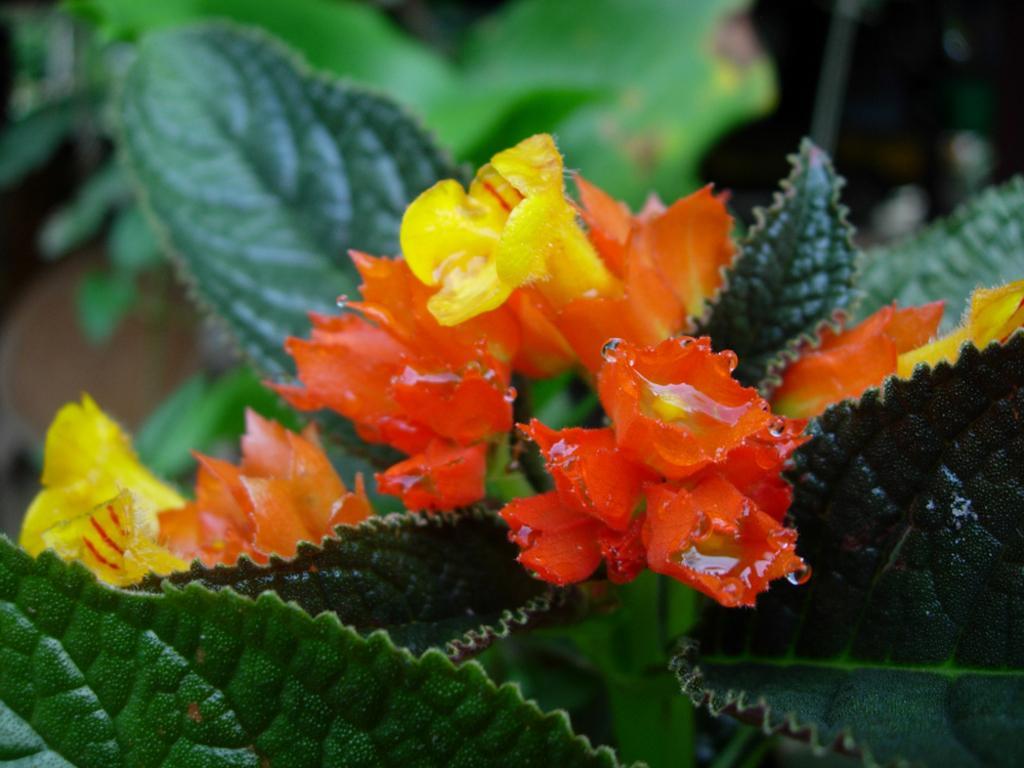Please provide a concise description of this image. In this picture we can see few flowers, leaves and blurry background. 